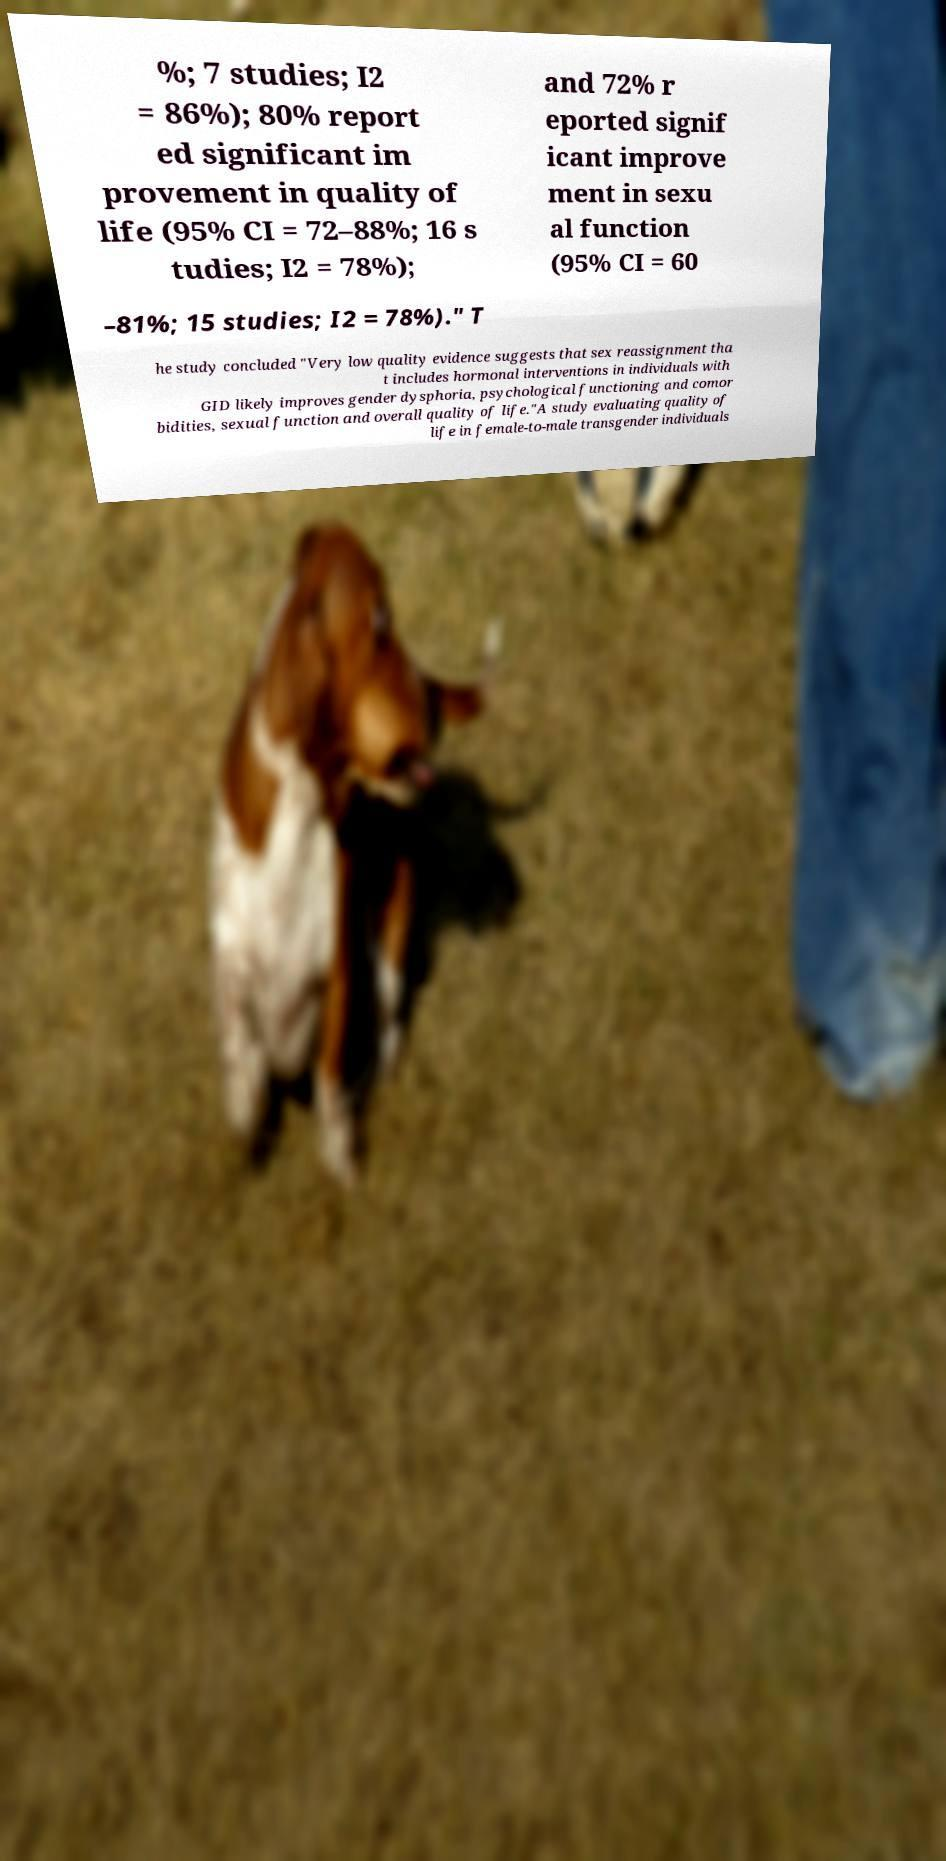What messages or text are displayed in this image? I need them in a readable, typed format. %; 7 studies; I2 = 86%); 80% report ed significant im provement in quality of life (95% CI = 72–88%; 16 s tudies; I2 = 78%); and 72% r eported signif icant improve ment in sexu al function (95% CI = 60 –81%; 15 studies; I2 = 78%)." T he study concluded "Very low quality evidence suggests that sex reassignment tha t includes hormonal interventions in individuals with GID likely improves gender dysphoria, psychological functioning and comor bidities, sexual function and overall quality of life."A study evaluating quality of life in female-to-male transgender individuals 